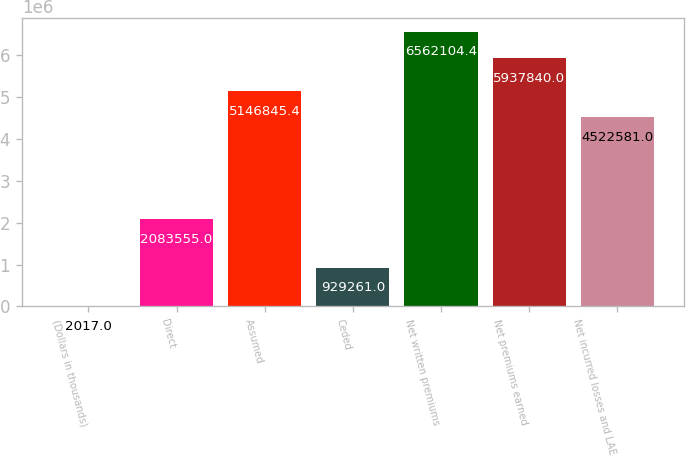<chart> <loc_0><loc_0><loc_500><loc_500><bar_chart><fcel>(Dollars in thousands)<fcel>Direct<fcel>Assumed<fcel>Ceded<fcel>Net written premiums<fcel>Net premiums earned<fcel>Net incurred losses and LAE<nl><fcel>2017<fcel>2.08356e+06<fcel>5.14685e+06<fcel>929261<fcel>6.5621e+06<fcel>5.93784e+06<fcel>4.52258e+06<nl></chart> 